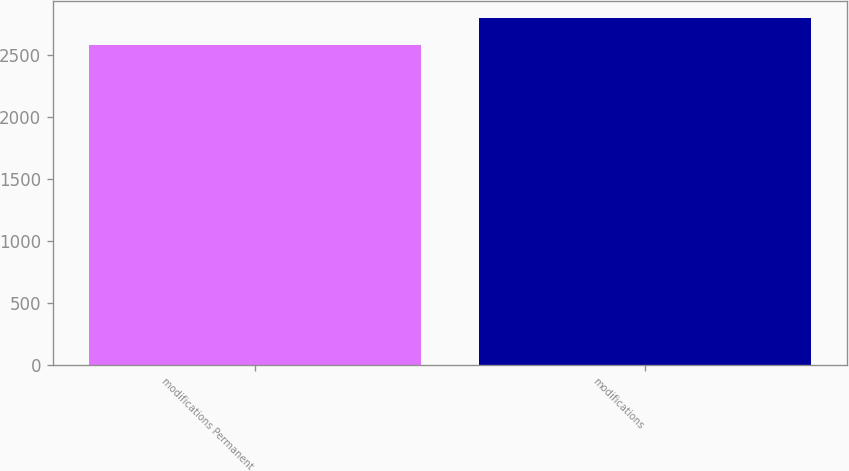Convert chart. <chart><loc_0><loc_0><loc_500><loc_500><bar_chart><fcel>modifications Permanent<fcel>modifications<nl><fcel>2581<fcel>2798<nl></chart> 